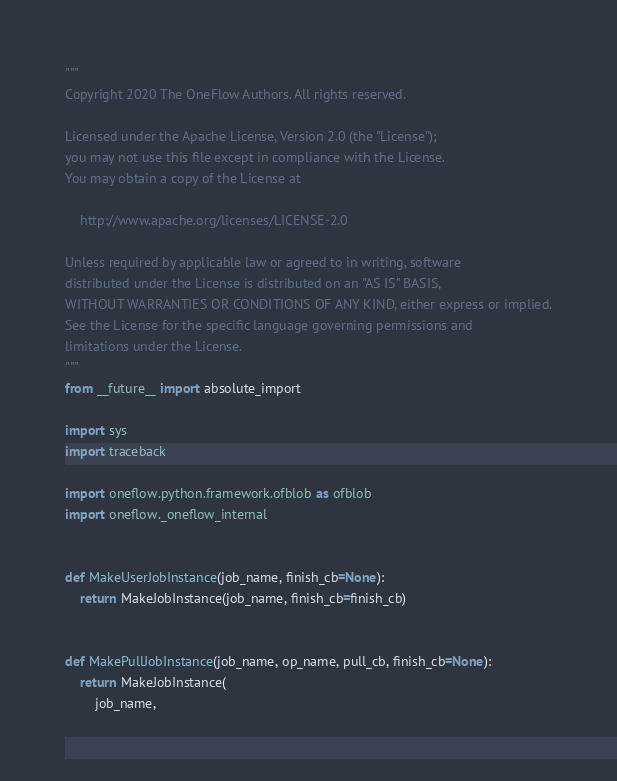<code> <loc_0><loc_0><loc_500><loc_500><_Python_>"""
Copyright 2020 The OneFlow Authors. All rights reserved.

Licensed under the Apache License, Version 2.0 (the "License");
you may not use this file except in compliance with the License.
You may obtain a copy of the License at

    http://www.apache.org/licenses/LICENSE-2.0

Unless required by applicable law or agreed to in writing, software
distributed under the License is distributed on an "AS IS" BASIS,
WITHOUT WARRANTIES OR CONDITIONS OF ANY KIND, either express or implied.
See the License for the specific language governing permissions and
limitations under the License.
"""
from __future__ import absolute_import

import sys
import traceback

import oneflow.python.framework.ofblob as ofblob
import oneflow._oneflow_internal


def MakeUserJobInstance(job_name, finish_cb=None):
    return MakeJobInstance(job_name, finish_cb=finish_cb)


def MakePullJobInstance(job_name, op_name, pull_cb, finish_cb=None):
    return MakeJobInstance(
        job_name,</code> 